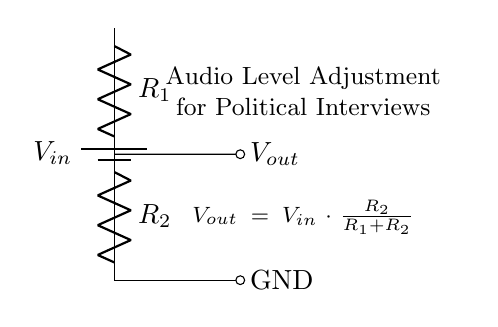What is the input voltage in this circuit? The circuit diagram shows a battery labeled V_in, which represents the input voltage. There is no specific value mentioned for V_in, but it is crucial as the source for the voltage divider.
Answer: V_in What are the resistance values in this circuit? The component labels R_1 and R_2 indicate the two resistors in the voltage divider circuit. However, specific resistance values are not provided in the diagram, only their symbolic representation.
Answer: R_1, R_2 What is the output voltage formula given in the circuit? The circuit notation includes the formula V_out = V_in · (R_2 / (R_1 + R_2)). This formula describes how the output voltage is derived from the input voltage based on the resistor values.
Answer: V_out = V_in · (R_2 / (R_1 + R_2)) If R_1 is twice the value of R_2, what can you say about V_out? The relationship given by the formula shows that if R_1 is twice R_2, the output voltage V_out will be one-third of the input voltage V_in. This is derived from substituting the ratio into the formula.
Answer: V_out = V_in / 3 What type of circuit is represented in the diagram? The circuit is a voltage divider, which is specifically designed to adjust voltage levels; this is evident from the configuration of the resistors and their output.
Answer: Voltage divider What is the purpose of this circuit in political interviews? The circuit is designed for audio level adjustment during recording, ensuring appropriate signal levels that are critical for clear dialogue in interviews.
Answer: Audio level adjustment What happens to V_out if R_2 is changed to a much lower resistance value? Reducing R_2 will increase the output voltage V_out as the divisor R_2 in the formula becomes smaller compared to R_1, thereby raising the overall ratio.
Answer: V_out increases 